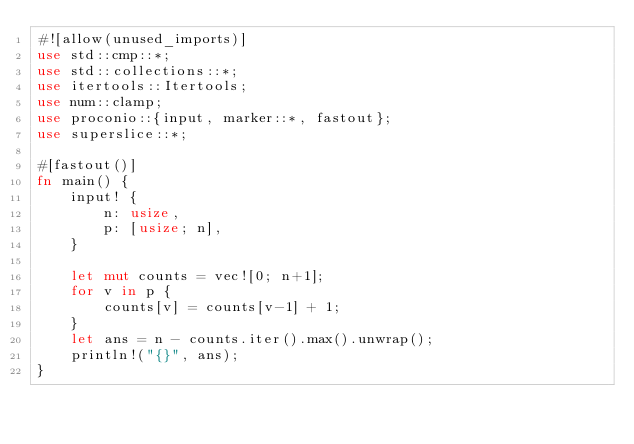Convert code to text. <code><loc_0><loc_0><loc_500><loc_500><_Rust_>#![allow(unused_imports)]
use std::cmp::*;
use std::collections::*;
use itertools::Itertools;
use num::clamp;
use proconio::{input, marker::*, fastout};
use superslice::*;

#[fastout()]
fn main() {
    input! {
        n: usize,
        p: [usize; n],
    }

    let mut counts = vec![0; n+1];
    for v in p {
        counts[v] = counts[v-1] + 1;
    }
    let ans = n - counts.iter().max().unwrap();
    println!("{}", ans);
}
</code> 